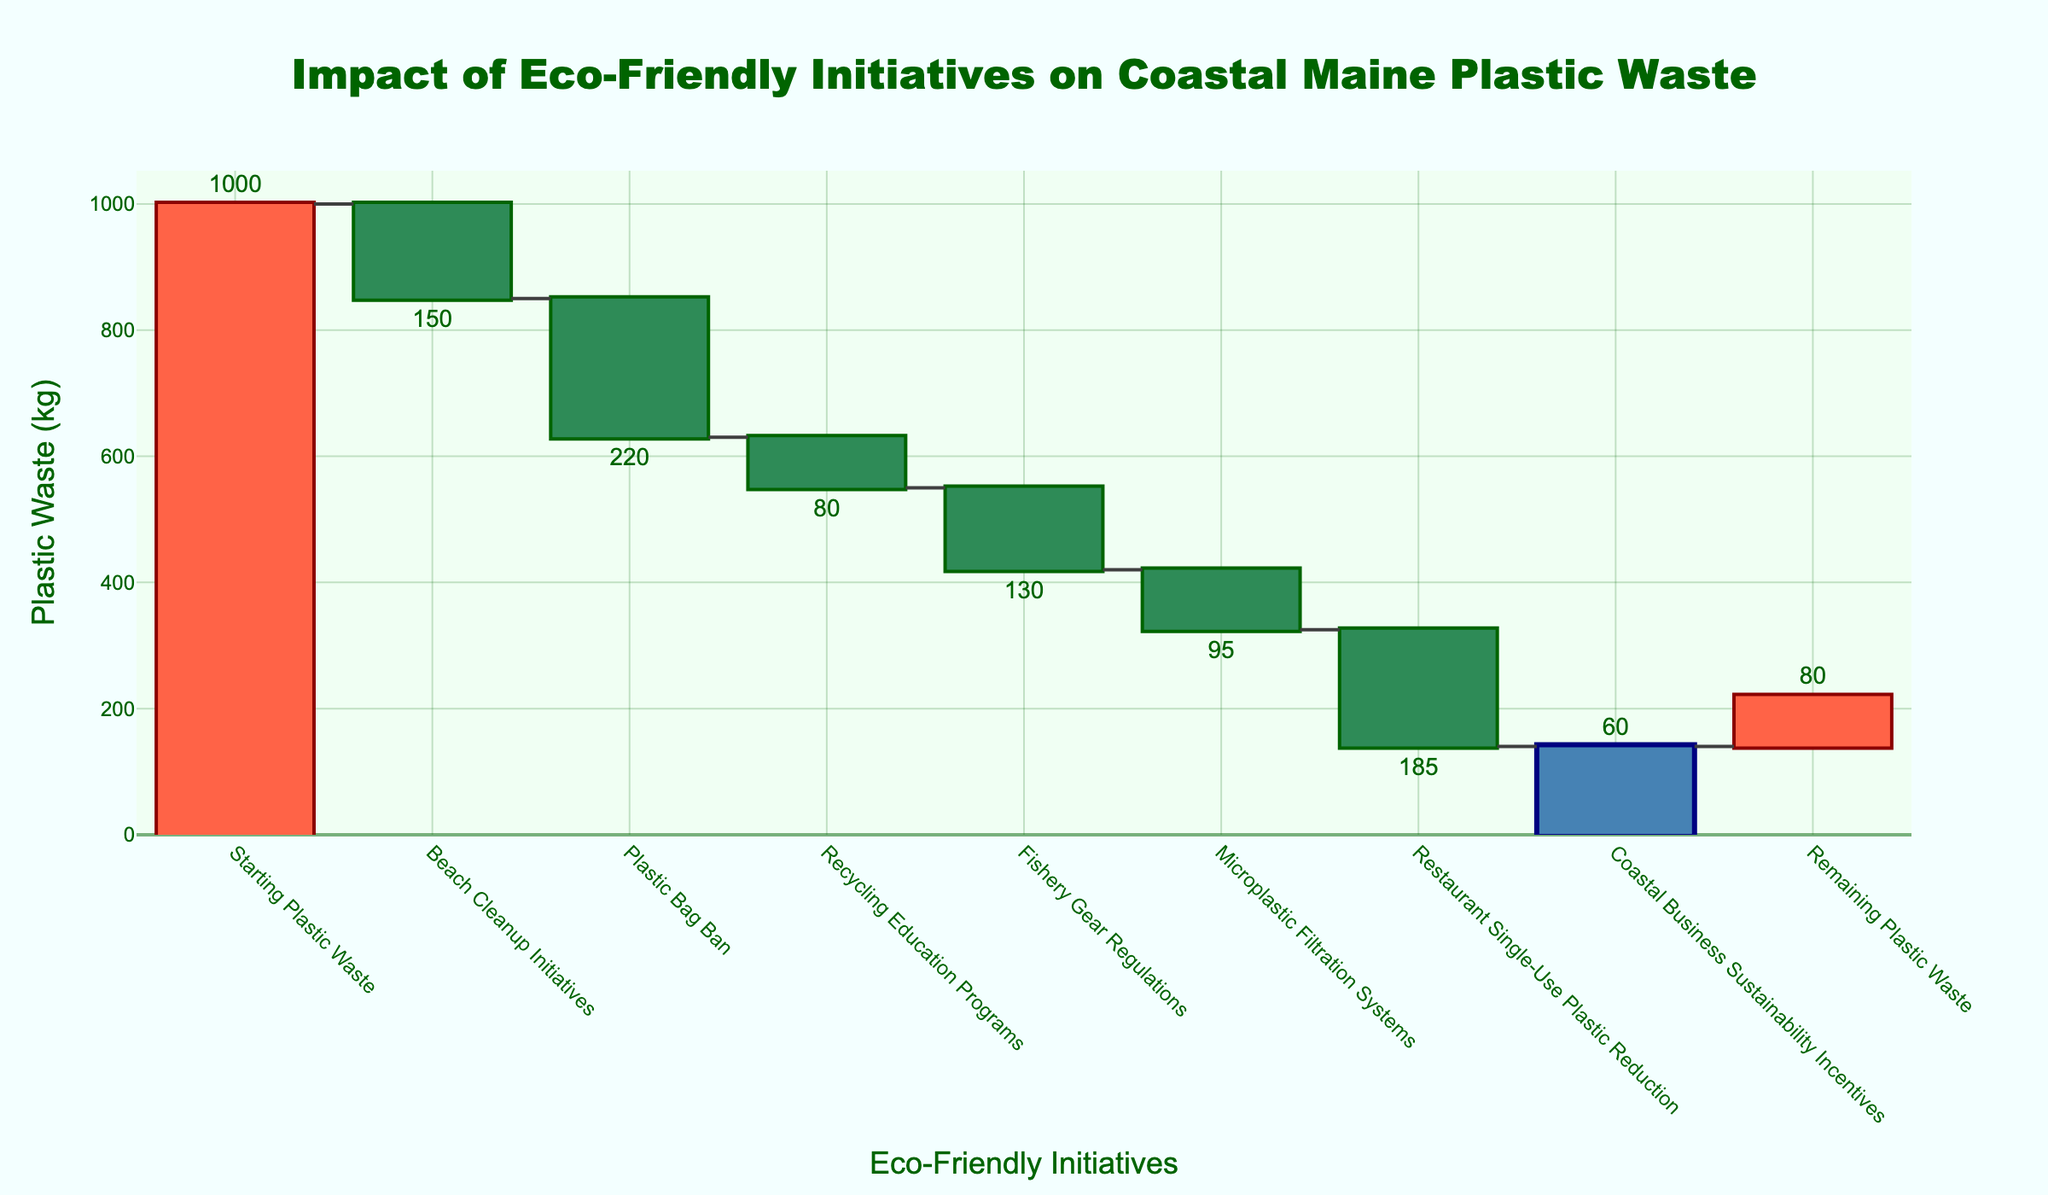What's the title of the figure? The title is usually found at the top of the figure and describes what the chart is about.
Answer: Impact of Eco-Friendly Initiatives on Coastal Maine Plastic Waste How many eco-friendly initiatives are represented in the figure? By counting the different initiatives listed along the x-axis, including the starting and ending points, you can determine the number of initiatives.
Answer: 7 What was the starting plastic waste amount? The starting amount is denoted in the first category of the x-axis, which reads "Starting Plastic Waste", and the corresponding y-value.
Answer: 1000 kg Which initiative had the highest reduction in plastic waste? By evaluating the distances each bar falls below zero on the y-axis, you can identify the initiative with the largest negative impact.
Answer: Plastic Bag Ban What's the remaining plastic waste after all initiatives? The last category on the x-axis, labeled "Remaining Plastic Waste", denotes the final amount after all reductions.
Answer: 80 kg Which initiatives had a reduction of less than 100 kg of plastic waste? By referring to the heights of the bars, find the initiatives whose reductions are less than 100 kg.
Answer: Recycling Education Programs, Microplastic Filtration Systems, Coastal Business Sustainability Incentives How much total plastic waste was reduced by all initiatives combined? Sum up all the individual reductions listed in the y-values to get the total reduction.
Answer: 920 kg How does the plastic waste reduction from "Beach Cleanup Initiatives" compare to "Restaurant Single-Use Plastic Reduction"? Compare the numerical values of the reductions in their respective bars.
Answer: Restaurant Single-Use Plastic Reduction had a higher reduction What is the difference in the plastic waste reduction between "Fishery Gear Regulations" and "Plastic Bag Ban"? Subtract the reduction achieved by "Fishery Gear Regulations" from that of "Plastic Bag Ban".
Answer: 90 kg Which initiative contributed the least to reducing plastic waste? Identify the initiative with the smallest negative value on the y-axis.
Answer: Coastal Business Sustainability Incentives 